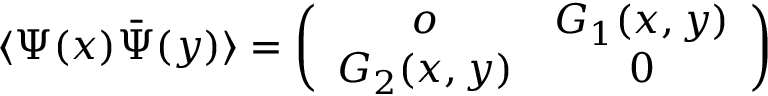Convert formula to latex. <formula><loc_0><loc_0><loc_500><loc_500>\langle \Psi ( x ) \bar { \Psi } ( y ) \rangle = \left ( \begin{array} { c c } { o } & { { G _ { 1 } ( x , y ) } } \\ { { G _ { 2 } ( x , y ) } } & { 0 } \end{array} \right )</formula> 